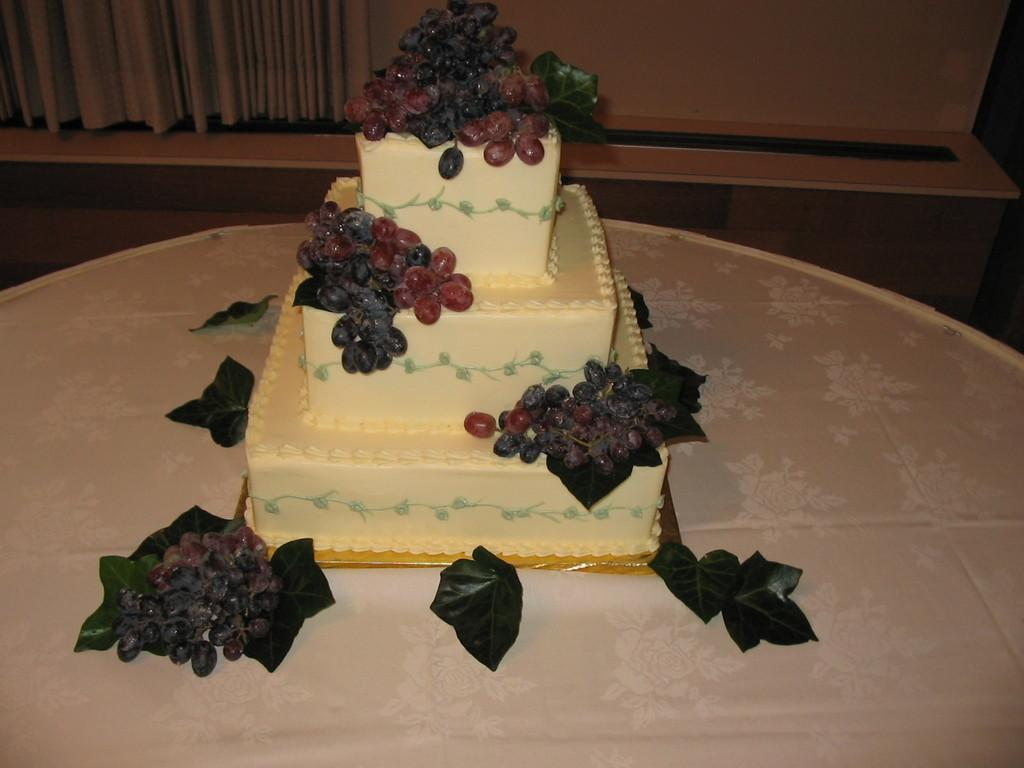What is the main subject of the image? There is a cake in the image. What decorations are on the cake? Grapes and leaves are placed on the cake. What can be seen in the background of the image? There are curtains in the background of the image. How many cars are parked on top of the cake in the image? There are no cars present in the image, as it features a cake with grapes and leaves as decorations. 